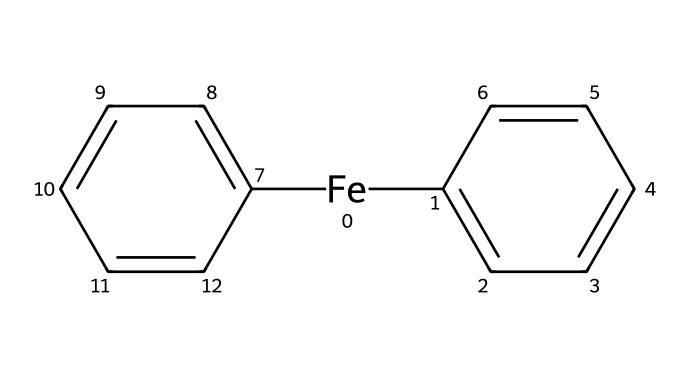What is the central metal in this compound? The chemical structure features an iron atom surrounded by two cyclopentadienyl anions, which indicates that iron is the central metal in ferrocene.
Answer: iron How many cyclopentadienyl rings are present? Analyzing the SMILES representation, it shows two identical cyclopentadienyl ring structures that bond to the iron atom, confirming their presence.
Answer: two What type of bonding is primarily present in ferrocene? Ferrocene exhibits metallic and covalent bonding between the iron atom and the cyclopentadienyl rings, evidenced by the non-ionic nature of the bonding in the organometallic compound.
Answer: covalent What is the symmetry of the molecule? The structure exhibits a symmetrical arrangement with two identical cyclopentadienyl rings aligned vertically and evenly spaced around a central iron atom, leading to its characteristic symmetry.
Answer: D5h How many carbon atoms are in each cyclopentadienyl ring? Each cyclopentadienyl ring, as seen in the chemical structure, comprises five carbon atoms, consistent with the definition of this cyclic compound.
Answer: five What role does the iron atom serve in this organometallic compound? The iron atom in ferrocene serves as a central coordinating metal, participating in electron donation and stabilizing the overall structure of the compound through bonding with the cyclopentadienyl ligands.
Answer: coordinating metal How does the structure of ferrocene affect its solubility in organic solvents? The balance of polar and non-polar characteristics, along with the presence of the non-polar cyclopentadienyl rings, typically contributes to ferrocene's increased solubility in organic solvents compared to aqueous solutions.
Answer: increases solubility 